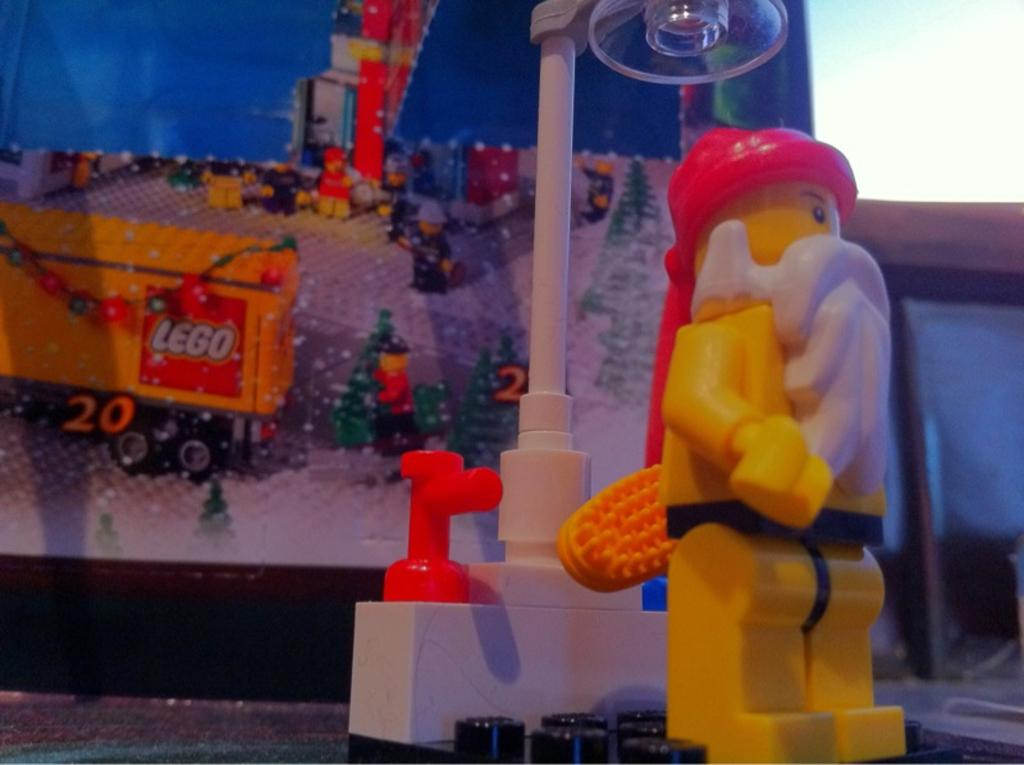What object can be seen in the image? There is a toy in the image. What can be seen in the background of the image? There are building blocks in the background of the image. What material are the building blocks made of? The building blocks are made of Lego bricks. Is there a flame visible near the toy in the image? No, there is no flame visible in the image. 